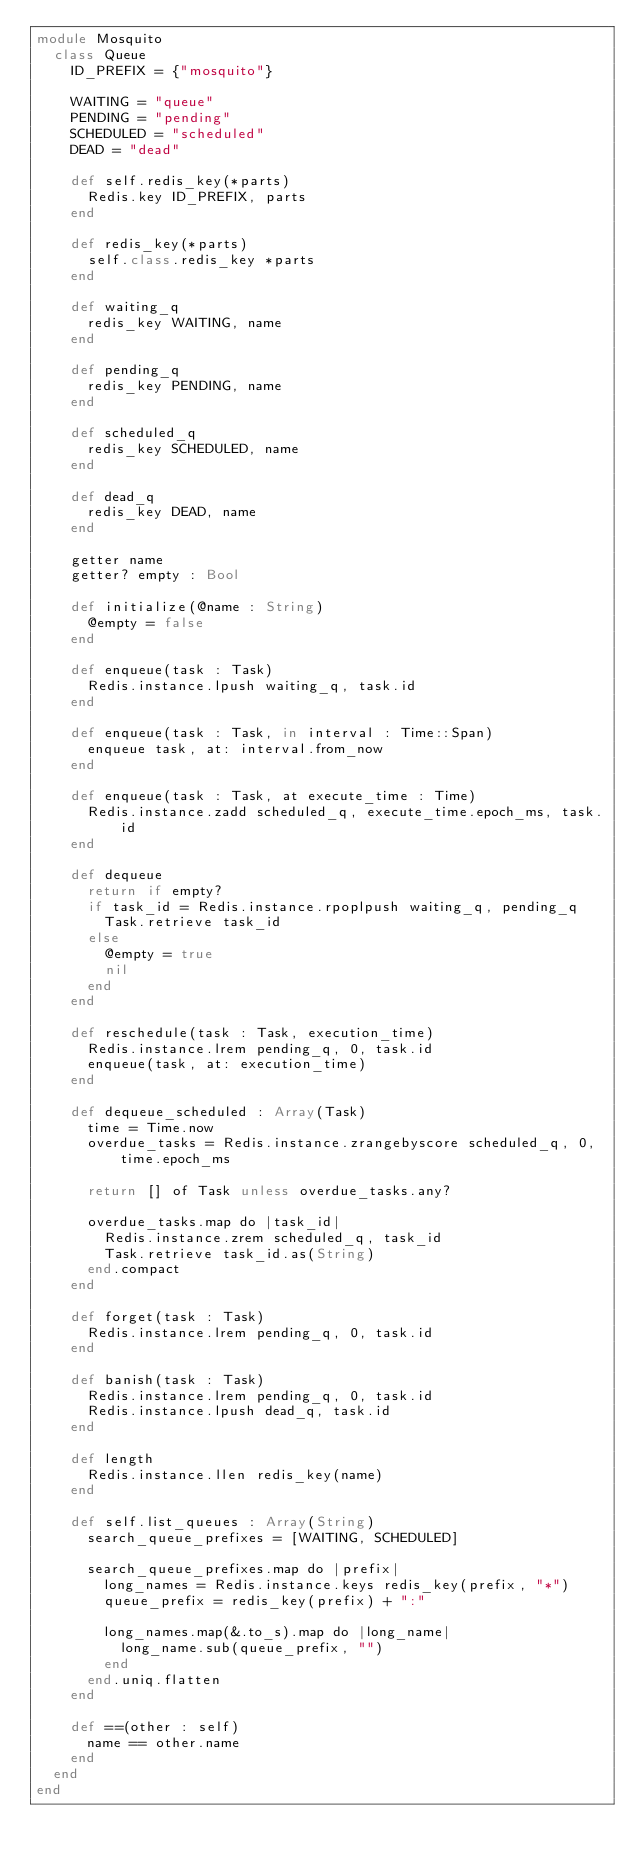Convert code to text. <code><loc_0><loc_0><loc_500><loc_500><_Crystal_>module Mosquito
  class Queue
    ID_PREFIX = {"mosquito"}

    WAITING = "queue"
    PENDING = "pending"
    SCHEDULED = "scheduled"
    DEAD = "dead"

    def self.redis_key(*parts)
      Redis.key ID_PREFIX, parts
    end

    def redis_key(*parts)
      self.class.redis_key *parts
    end

    def waiting_q
      redis_key WAITING, name
    end

    def pending_q
      redis_key PENDING, name
    end

    def scheduled_q
      redis_key SCHEDULED, name
    end

    def dead_q
      redis_key DEAD, name
    end

    getter name
    getter? empty : Bool

    def initialize(@name : String)
      @empty = false
    end

    def enqueue(task : Task)
      Redis.instance.lpush waiting_q, task.id
    end

    def enqueue(task : Task, in interval : Time::Span)
      enqueue task, at: interval.from_now
    end

    def enqueue(task : Task, at execute_time : Time)
      Redis.instance.zadd scheduled_q, execute_time.epoch_ms, task.id
    end

    def dequeue
      return if empty?
      if task_id = Redis.instance.rpoplpush waiting_q, pending_q
        Task.retrieve task_id
      else
        @empty = true
        nil
      end
    end

    def reschedule(task : Task, execution_time)
      Redis.instance.lrem pending_q, 0, task.id
      enqueue(task, at: execution_time)
    end

    def dequeue_scheduled : Array(Task)
      time = Time.now
      overdue_tasks = Redis.instance.zrangebyscore scheduled_q, 0, time.epoch_ms

      return [] of Task unless overdue_tasks.any?

      overdue_tasks.map do |task_id|
        Redis.instance.zrem scheduled_q, task_id
        Task.retrieve task_id.as(String)
      end.compact
    end

    def forget(task : Task)
      Redis.instance.lrem pending_q, 0, task.id
    end

    def banish(task : Task)
      Redis.instance.lrem pending_q, 0, task.id
      Redis.instance.lpush dead_q, task.id
    end

    def length
      Redis.instance.llen redis_key(name)
    end

    def self.list_queues : Array(String)
      search_queue_prefixes = [WAITING, SCHEDULED]

      search_queue_prefixes.map do |prefix|
        long_names = Redis.instance.keys redis_key(prefix, "*")
        queue_prefix = redis_key(prefix) + ":"

        long_names.map(&.to_s).map do |long_name|
          long_name.sub(queue_prefix, "")
        end
      end.uniq.flatten
    end

    def ==(other : self)
      name == other.name
    end
  end
end
</code> 